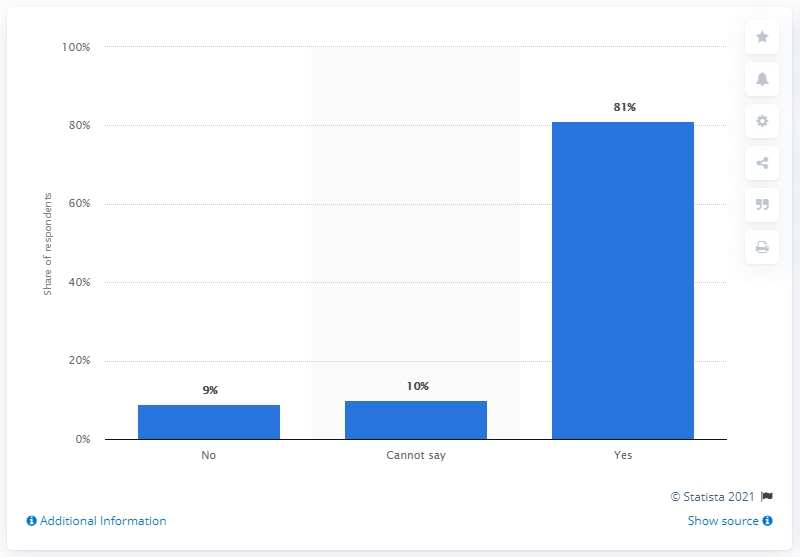Point out several critical features in this image. According to a survey conducted among Indian parents, 81% of them desired that schools should reopen on June 1, 2020. 